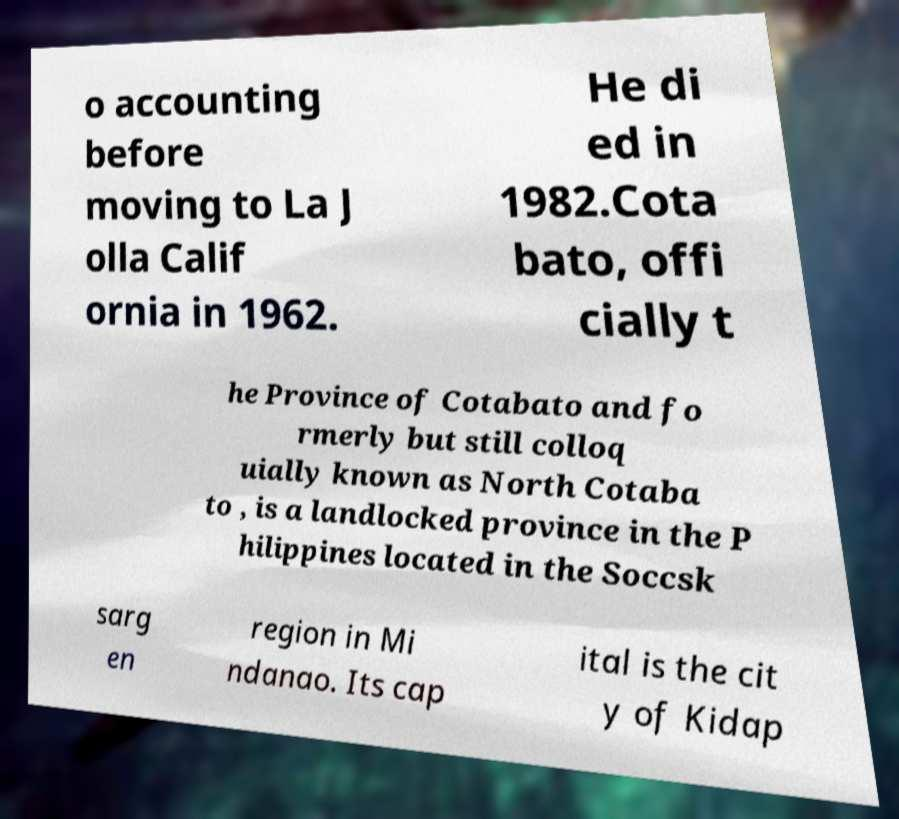Could you extract and type out the text from this image? o accounting before moving to La J olla Calif ornia in 1962. He di ed in 1982.Cota bato, offi cially t he Province of Cotabato and fo rmerly but still colloq uially known as North Cotaba to , is a landlocked province in the P hilippines located in the Soccsk sarg en region in Mi ndanao. Its cap ital is the cit y of Kidap 